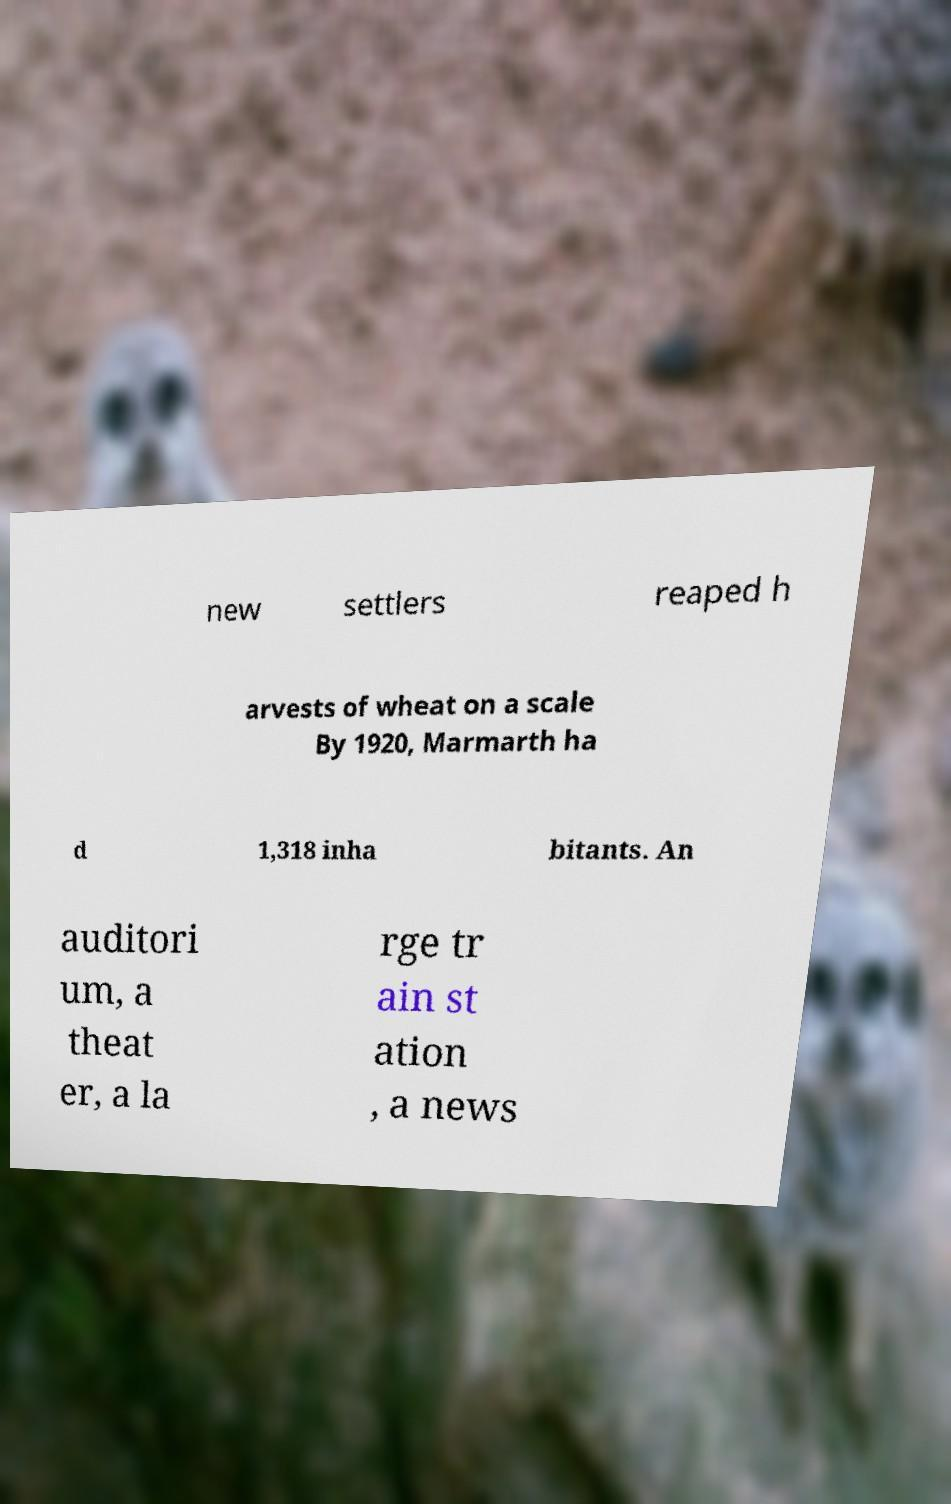There's text embedded in this image that I need extracted. Can you transcribe it verbatim? new settlers reaped h arvests of wheat on a scale By 1920, Marmarth ha d 1,318 inha bitants. An auditori um, a theat er, a la rge tr ain st ation , a news 